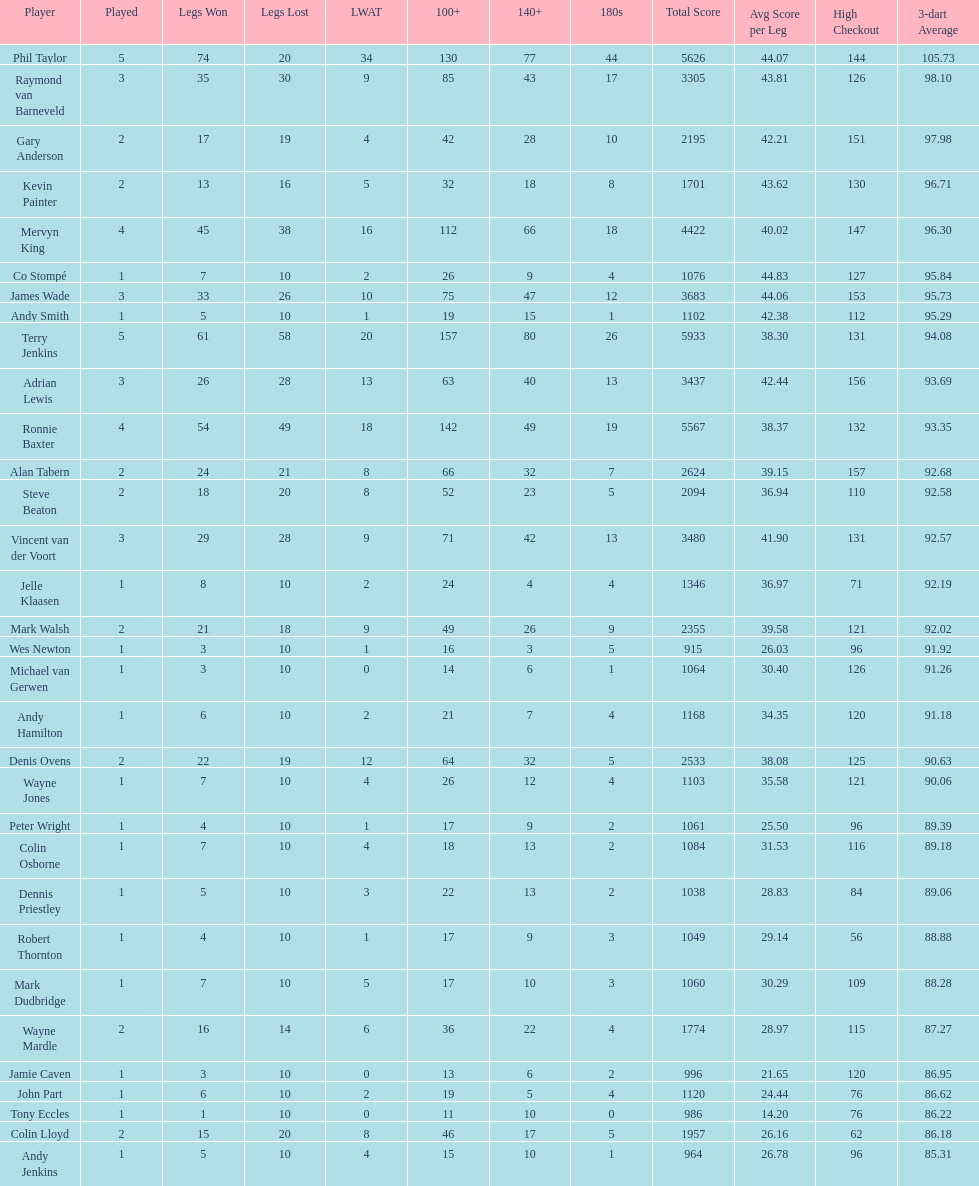Who won the highest number of legs in the 2009 world matchplay? Phil Taylor. 